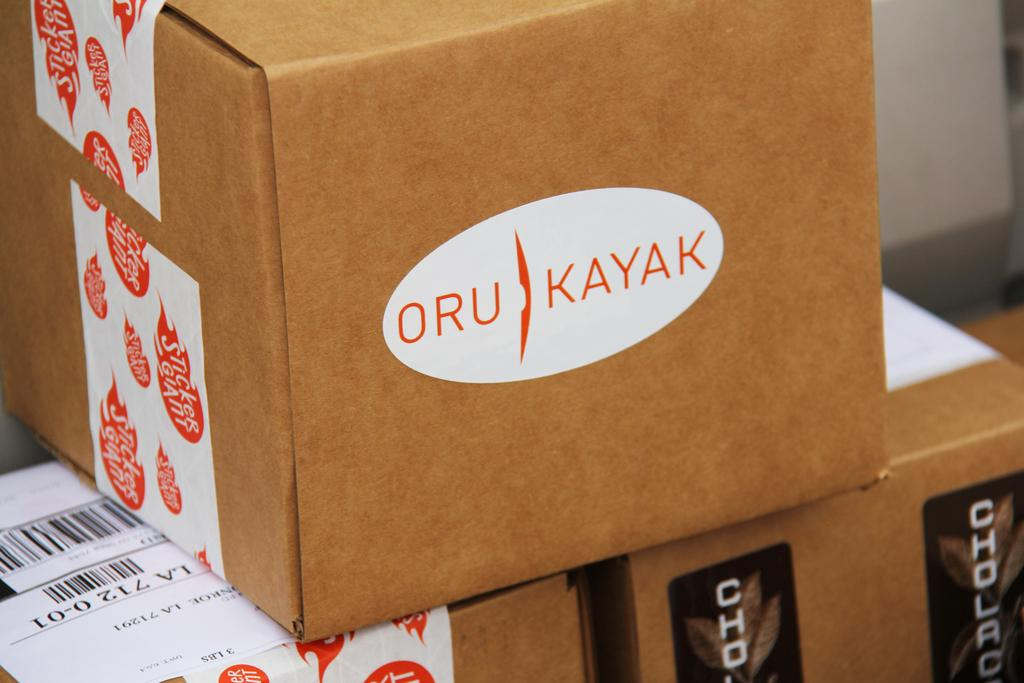Provide a one-sentence caption for the provided image. several brown cardboard boxes are stacked and the top one has a white oval with the letters ORU KAYAK on it. 